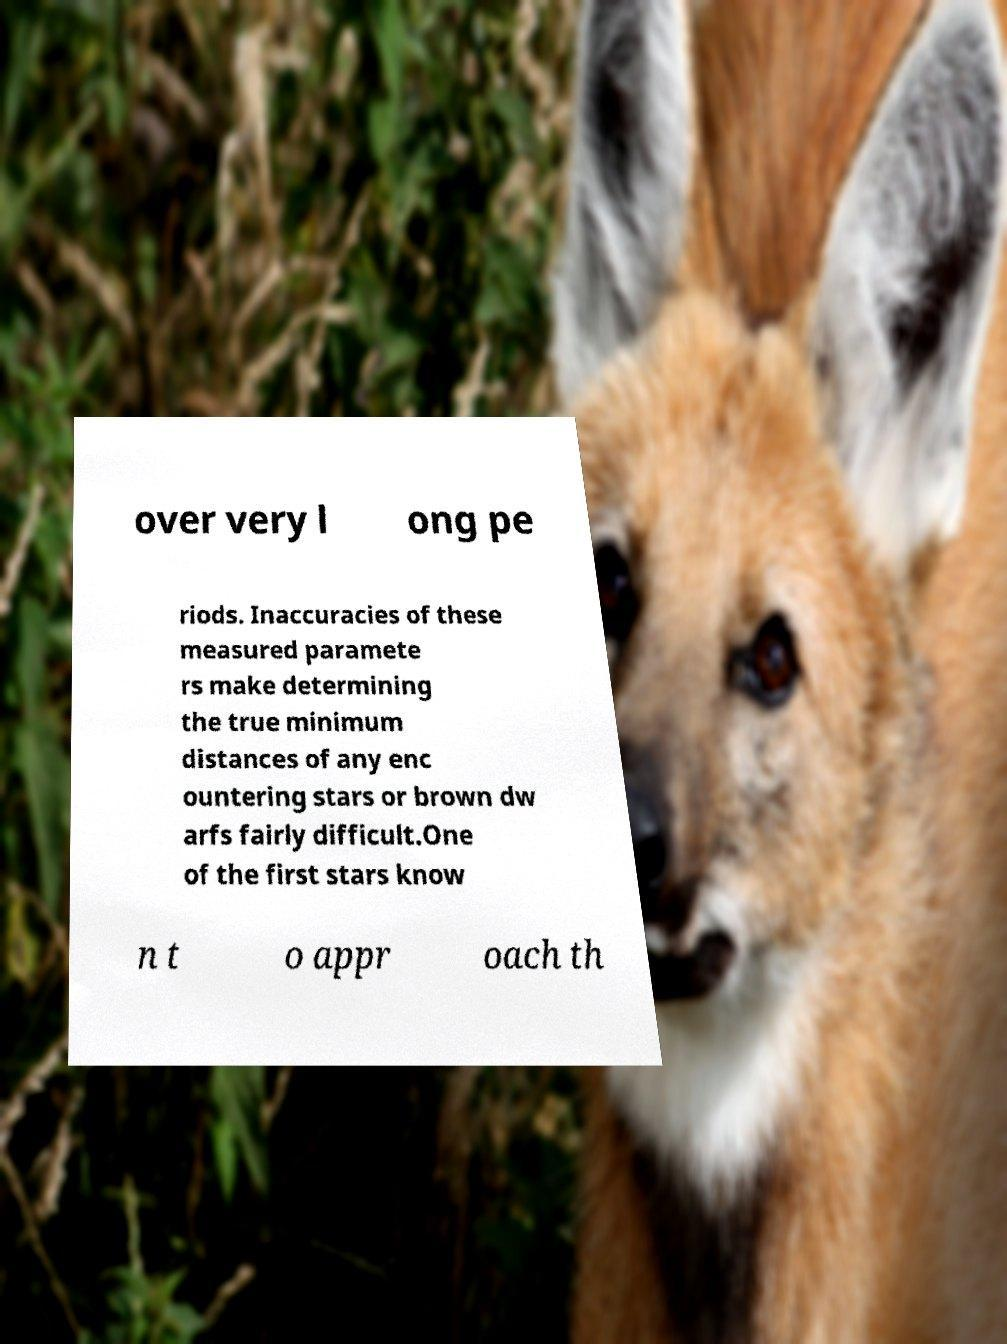Could you assist in decoding the text presented in this image and type it out clearly? over very l ong pe riods. Inaccuracies of these measured paramete rs make determining the true minimum distances of any enc ountering stars or brown dw arfs fairly difficult.One of the first stars know n t o appr oach th 